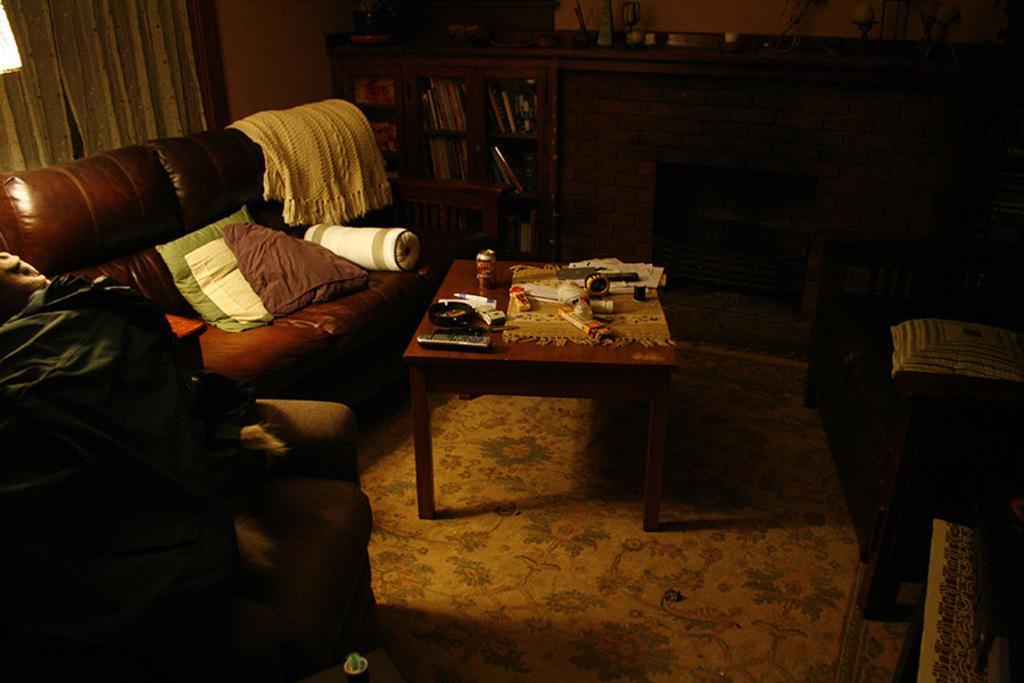Describe this image in one or two sentences. This picture shows a room with the sofa, table on which some accessories were placed. Here is a pillow. In the background, there is a bookshelf in which some books are placed and we can see some curtains and a wall here. 